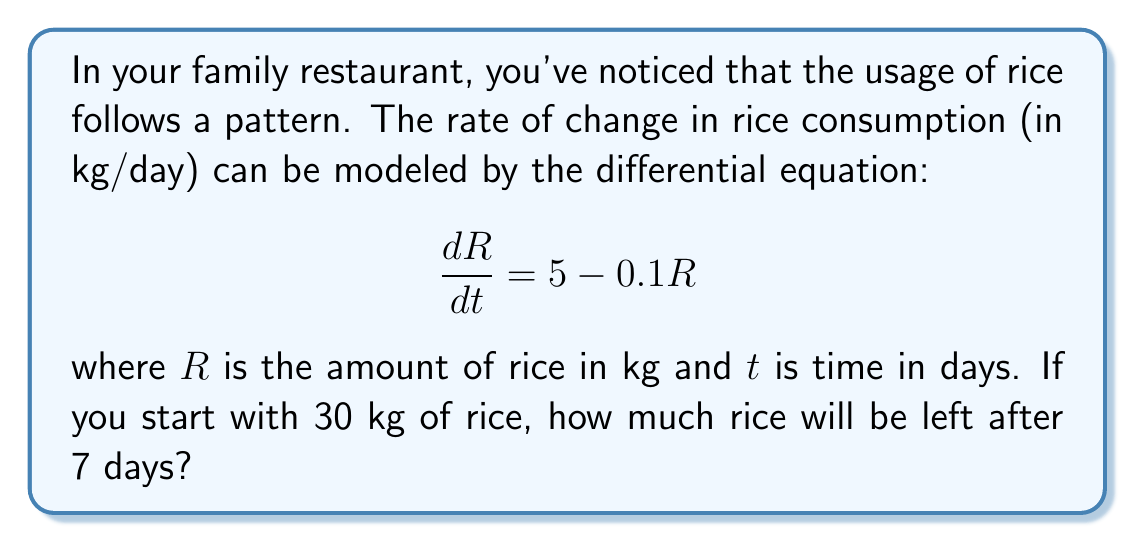Could you help me with this problem? To solve this problem, we need to use the given differential equation and initial condition:

1) The differential equation is: $\frac{dR}{dt} = 5 - 0.1R$

2) This is a first-order linear differential equation. The general solution is:

   $R(t) = 50 + Ce^{-0.1t}$

   where $C$ is a constant to be determined by the initial condition.

3) Initial condition: At $t=0$, $R=30$. Let's substitute this:

   $30 = 50 + C$
   $C = -20$

4) So, the particular solution is:

   $R(t) = 50 - 20e^{-0.1t}$

5) To find the amount of rice after 7 days, we substitute $t=7$:

   $R(7) = 50 - 20e^{-0.1(7)}$
         $= 50 - 20e^{-0.7}$
         $= 50 - 20(0.4966)$
         $= 50 - 9.932$
         $= 40.068$ kg

Therefore, after 7 days, there will be approximately 40.07 kg of rice left.
Answer: 40.07 kg 